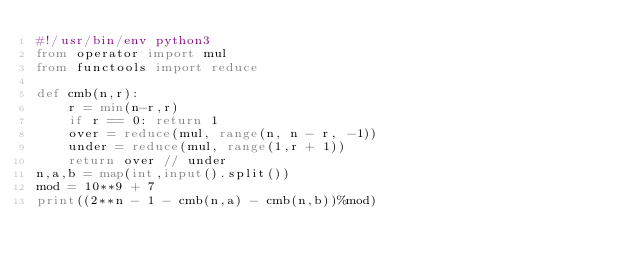Convert code to text. <code><loc_0><loc_0><loc_500><loc_500><_Python_>#!/usr/bin/env python3
from operator import mul
from functools import reduce

def cmb(n,r):
    r = min(n-r,r)
    if r == 0: return 1
    over = reduce(mul, range(n, n - r, -1))
    under = reduce(mul, range(1,r + 1))
    return over // under
n,a,b = map(int,input().split())
mod = 10**9 + 7
print((2**n - 1 - cmb(n,a) - cmb(n,b))%mod)</code> 